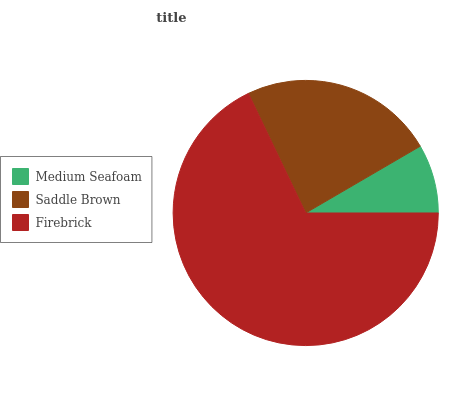Is Medium Seafoam the minimum?
Answer yes or no. Yes. Is Firebrick the maximum?
Answer yes or no. Yes. Is Saddle Brown the minimum?
Answer yes or no. No. Is Saddle Brown the maximum?
Answer yes or no. No. Is Saddle Brown greater than Medium Seafoam?
Answer yes or no. Yes. Is Medium Seafoam less than Saddle Brown?
Answer yes or no. Yes. Is Medium Seafoam greater than Saddle Brown?
Answer yes or no. No. Is Saddle Brown less than Medium Seafoam?
Answer yes or no. No. Is Saddle Brown the high median?
Answer yes or no. Yes. Is Saddle Brown the low median?
Answer yes or no. Yes. Is Firebrick the high median?
Answer yes or no. No. Is Firebrick the low median?
Answer yes or no. No. 